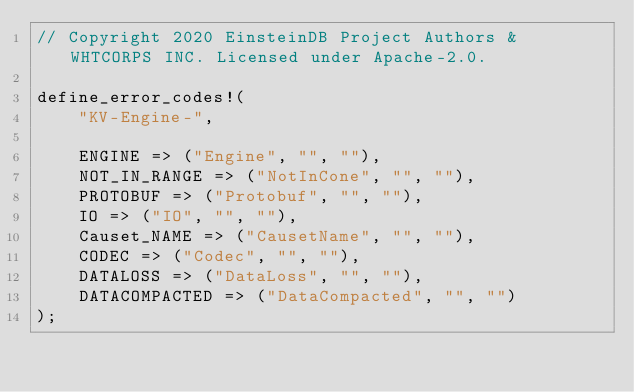<code> <loc_0><loc_0><loc_500><loc_500><_Rust_>// Copyright 2020 EinsteinDB Project Authors & WHTCORPS INC. Licensed under Apache-2.0.

define_error_codes!(
    "KV-Engine-",

    ENGINE => ("Engine", "", ""),
    NOT_IN_RANGE => ("NotInCone", "", ""),
    PROTOBUF => ("Protobuf", "", ""),
    IO => ("IO", "", ""),
    Causet_NAME => ("CausetName", "", ""),
    CODEC => ("Codec", "", ""),
    DATALOSS => ("DataLoss", "", ""),
    DATACOMPACTED => ("DataCompacted", "", "")
);
</code> 